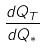Convert formula to latex. <formula><loc_0><loc_0><loc_500><loc_500>\frac { d Q _ { T } } { d Q _ { * } }</formula> 